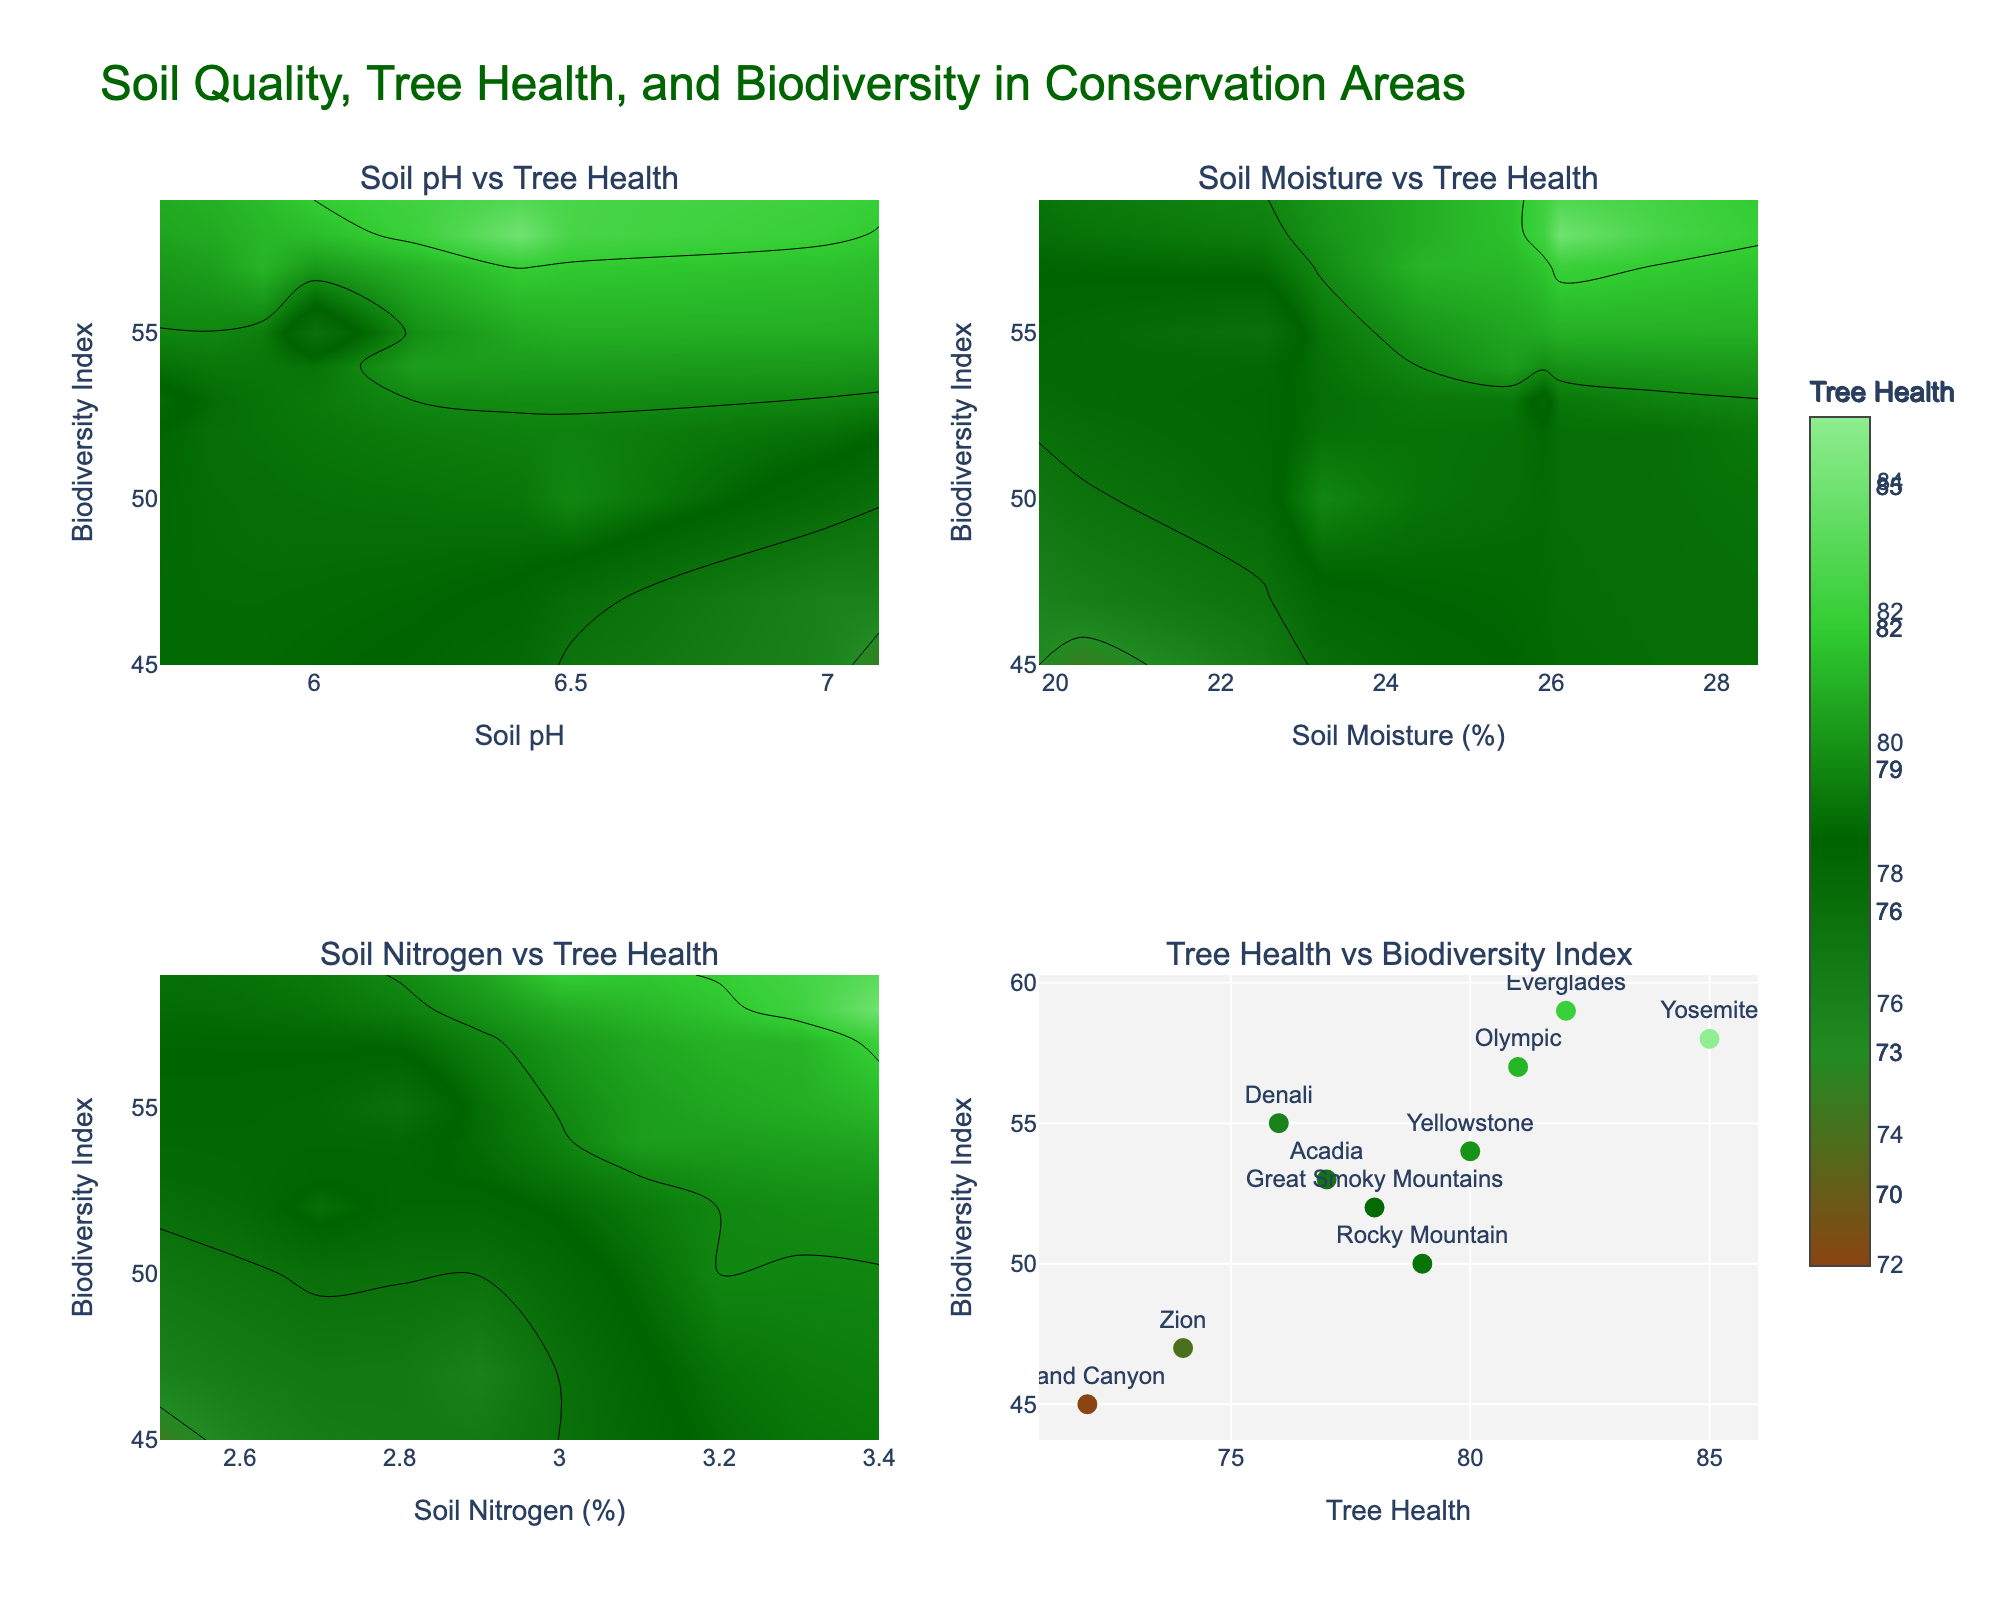What's the title of the figure? The title is usually placed at the top of the figure, and in this case, it clearly states the main subject of the plots.
Answer: Soil Quality, Tree Health, and Biodiversity in Conservation Areas How is "Tree Health" visually represented in the scatter plot? By looking at the scatter plot, we can see that 'Tree Health' values are used both as the color of the markers and one of the axes (x-axis).
Answer: As the marker colors and the x-axis Which subplot shows the relationship between Soil pH and Tree Health? In the overall layout of the subplots, the title under the first subplot helps identify it.
Answer: The top-left subplot What is the range of Tree Health values used in the contour plots? The colorbar next to the contour plots has labels that indicate the range of Tree Health values.
Answer: 70 to 85 Is there a positive correlation between Tree Health and Biodiversity Index in the scatter plot? By observing the general trend of points in the scatter plot, if they form an upward pattern, this indicates a positive correlation.
Answer: Yes Which conservation area has the highest Biodiversity Index, and what is its Tree Health value? In the scatter plot, look for the highest point on the y-axis (Biodiversity Index) and read its Tree Health value from the x-axis. Check the associated text label for the conservation area.
Answer: Everglades, Tree Health: 82 Are areas with higher Soil Nitrogen levels correlated with higher or lower Tree Health according to the related contour plot? By examining the contour plot for Soil Nitrogen vs Tree Health, observe whether higher Soil Nitrogen levels fall in regions with higher or lower Tree Health.
Answer: Higher Tree Health Compare the influence of Soil Moisture and Soil pH on Tree Health. Which appears to have a stronger effect based on the contour plots? By comparing the contour plot gradients and the range of Tree Health values they cover, assess which shows more pronounced variations.
Answer: Soil Moisture Does any subplot indicate a relationship between soil conditions and biodiversity directly? By examining each plot, note that the scatter plot directly compares Tree Health to Biodiversity, but no subplot directly correlates soil conditions with biodiversity.
Answer: No Which axis is used for Biodiversity Index in the subplots? By looking at the axes titles and the positioning, the Biodiversity Index titles are consistently on the vertical axis (y-axis) of the subplots.
Answer: Y-axis 